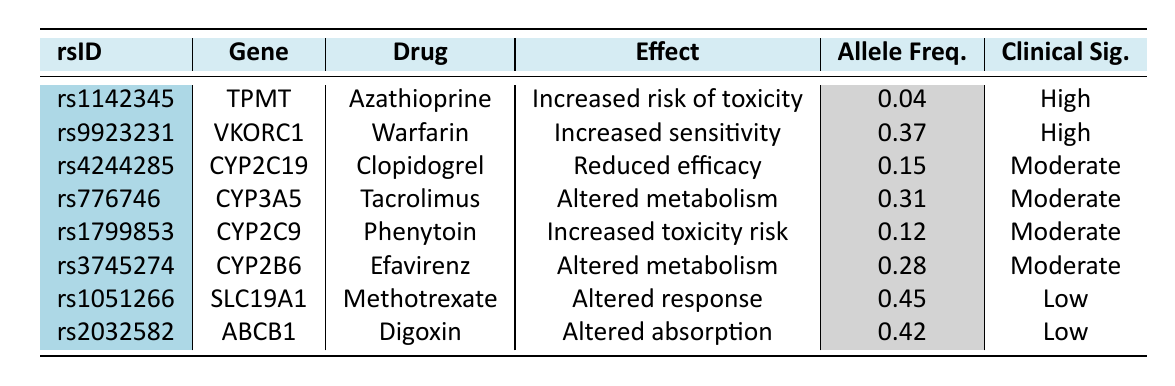What is the effect of SNP rs1142345 on drug Azathioprine? The table states that SNP rs1142345 is linked to the gene TPMT and has an effect of "Increased risk of toxicity" when administering the drug Azathioprine.
Answer: Increased risk of toxicity Which drug is associated with the SNP rs9923231? The SNP rs9923231 is associated with the drug Warfarin, as indicated in the table under the "Drug" column for that rsID.
Answer: Warfarin What is the clinical significance of SNP rs4244285? The table shows that SNP rs4244285 has a "Moderate" clinical significance level.
Answer: Moderate How many SNPs are linked to drugs with "High" clinical significance? According to the table, there are 2 SNPs (rs1142345 and rs9923231) that are classified under "High" clinical significance.
Answer: 2 What is the allele frequency of SNP rs2032582? The table lists the allele frequency of SNP rs2032582 as 0.42 in the corresponding cell under the "Allele Freq." column.
Answer: 0.42 Is the effect of SNP rs3745274 associated with altered metabolism? The data specifies that SNP rs3745274, related to CYP2B6 and the drug Efavirenz, has an effect listed as "Altered metabolism." Thus, the statement is true.
Answer: Yes Which drug has the highest allele frequency listed in the table? By examining the "Allele Freq." column, the drug Methotrexate (SNP rs1051266) has the highest frequency at 0.45 compared to others.
Answer: Methotrexate Calculate the average allele frequency of SNPs with "Moderate" clinical significance. The SNPs with "Moderate" significance are rs4244285, rs776746, rs1799853, and rs3745274. Their frequencies are 0.15, 0.31, 0.12, and 0.28, respectively. The average is (0.15 + 0.31 + 0.12 + 0.28) / 4 = 0.21.
Answer: 0.21 How many SNPs are associated with an increased risk of toxicity? From the table, SNPs rs1142345 and rs1799853 are associated with an increased risk of toxicity. Therefore, the total is 2 SNPs.
Answer: 2 What is the effect of the SNPs linked to the drug Clopidogrel? The effect of the SNP rs4244285 linked to the drug Clopidogrel is noted as "Reduced efficacy" in the table.
Answer: Reduced efficacy 